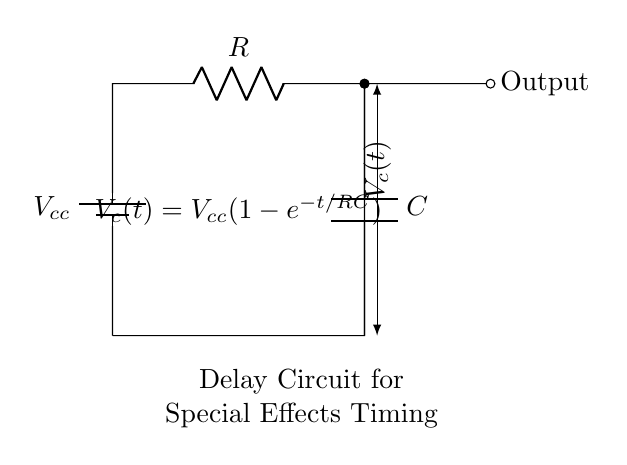What is the component labeled "R"? The component labeled "R" in the circuit diagram is a resistor, which is used to limit the current in the circuit.
Answer: Resistor What is the role of the capacitor in this circuit? The capacitor in this circuit is used to store electrical energy and release it at a controlled rate, creating a delay in the output signal.
Answer: Delay What is the output of this circuit? The output is taken from the point labeled "Output," which shows the voltage across the capacitor as it charges.
Answer: Voltage across the capacitor What does the equation \( V_c(t) = V_{cc}(1-e^{-t/RC}) \) represent? This equation represents the voltage across the capacitor as a function of time, showing how it charges exponentially based on the resistor and capacitor values.
Answer: Capacitor voltage over time How does changing the resistance \( R \) affect the delay in this circuit? Increasing the resistance \( R \) will increase the time constant \( \tau = RC \), resulting in a longer delay for the capacitor to charge and reach a certain voltage level, hence affecting the timing of special effects.
Answer: Increases delay What is the value of \( V_{cc} \) in the circuit? The voltage \( V_{cc} \) is the supply voltage provided to the circuit, which is not specified in the diagram but is assumed to be a constant voltage for operation.
Answer: Not specified Which component determines the charge time of the capacitor? The resistor \( R \) plays a crucial role in determining the charge time of the capacitor due to its effect on the time constant \( \tau = RC \).
Answer: Resistor 